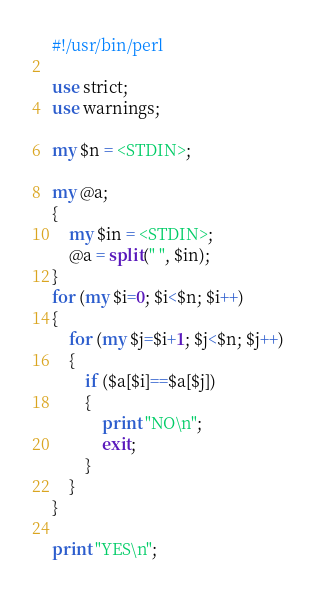<code> <loc_0><loc_0><loc_500><loc_500><_Perl_>#!/usr/bin/perl

use strict;
use warnings;

my $n = <STDIN>;

my @a;
{
    my $in = <STDIN>;
    @a = split(" ", $in);
}
for (my $i=0; $i<$n; $i++)
{
    for (my $j=$i+1; $j<$n; $j++)
    {
        if ($a[$i]==$a[$j])
        {
            print "NO\n";
            exit;
        }
    }
}

print "YES\n";</code> 